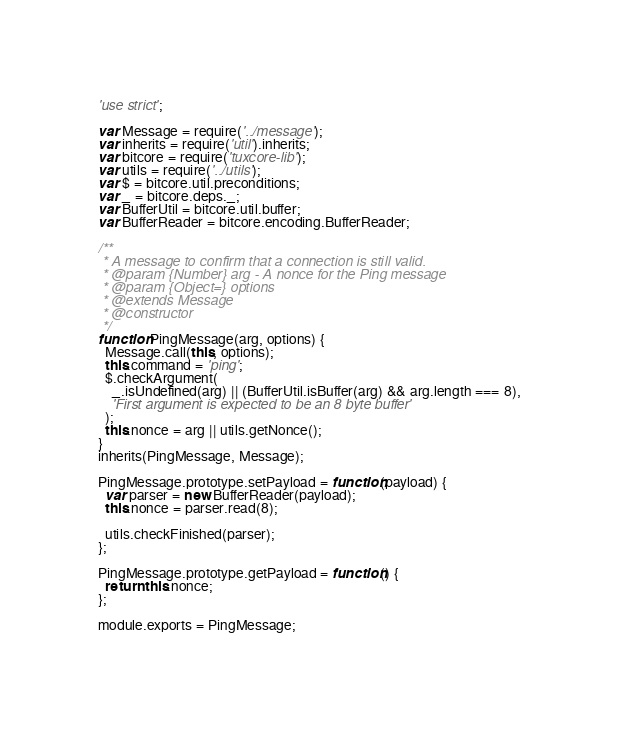<code> <loc_0><loc_0><loc_500><loc_500><_JavaScript_>'use strict';

var Message = require('../message');
var inherits = require('util').inherits;
var bitcore = require('tuxcore-lib');
var utils = require('../utils');
var $ = bitcore.util.preconditions;
var _ = bitcore.deps._;
var BufferUtil = bitcore.util.buffer;
var BufferReader = bitcore.encoding.BufferReader;

/**
 * A message to confirm that a connection is still valid.
 * @param {Number} arg - A nonce for the Ping message
 * @param {Object=} options
 * @extends Message
 * @constructor
 */
function PingMessage(arg, options) {
  Message.call(this, options);
  this.command = 'ping';
  $.checkArgument(
    _.isUndefined(arg) || (BufferUtil.isBuffer(arg) && arg.length === 8),
    'First argument is expected to be an 8 byte buffer'
  );
  this.nonce = arg || utils.getNonce();
}
inherits(PingMessage, Message);

PingMessage.prototype.setPayload = function(payload) {
  var parser = new BufferReader(payload);
  this.nonce = parser.read(8);

  utils.checkFinished(parser);
};

PingMessage.prototype.getPayload = function() {
  return this.nonce;
};

module.exports = PingMessage;
</code> 